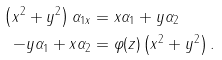<formula> <loc_0><loc_0><loc_500><loc_500>\left ( x ^ { 2 } + y ^ { 2 } \right ) \alpha _ { 1 x } & = x \alpha _ { 1 } + y \alpha _ { 2 } \\ - y \alpha _ { 1 } + x \alpha _ { 2 } & = \varphi ( z ) \left ( x ^ { 2 } + y ^ { 2 } \right ) .</formula> 